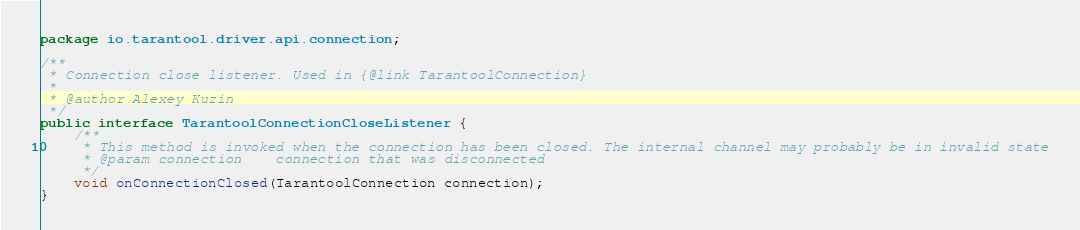Convert code to text. <code><loc_0><loc_0><loc_500><loc_500><_Java_>package io.tarantool.driver.api.connection;

/**
 * Connection close listener. Used in {@link TarantoolConnection}
 *
 * @author Alexey Kuzin
 */
public interface TarantoolConnectionCloseListener {
    /**
     * This method is invoked when the connection has been closed. The internal channel may probably be in invalid state
     * @param connection    connection that was disconnected
     */
    void onConnectionClosed(TarantoolConnection connection);
}
</code> 